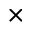Convert formula to latex. <formula><loc_0><loc_0><loc_500><loc_500>\times</formula> 